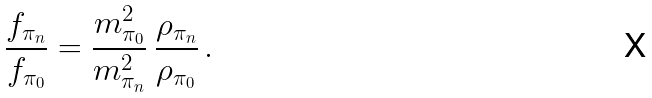Convert formula to latex. <formula><loc_0><loc_0><loc_500><loc_500>\frac { f _ { \pi _ { n } } } { f _ { \pi _ { 0 } } } = \frac { m _ { \pi _ { 0 } } ^ { 2 } } { m ^ { 2 } _ { \pi _ { n } } } \, \frac { \rho _ { \pi _ { n } } } { \rho _ { \pi _ { 0 } } } \, .</formula> 